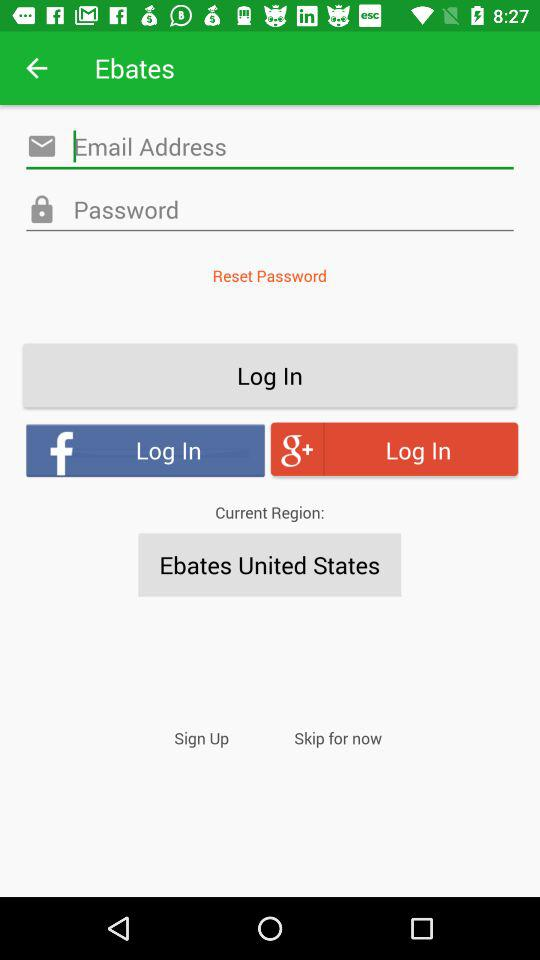What is the application name? The application name is "Ebates". 